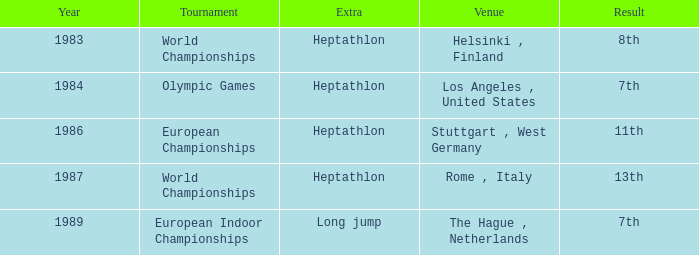How often are the Olympic games hosted? 1984.0. 